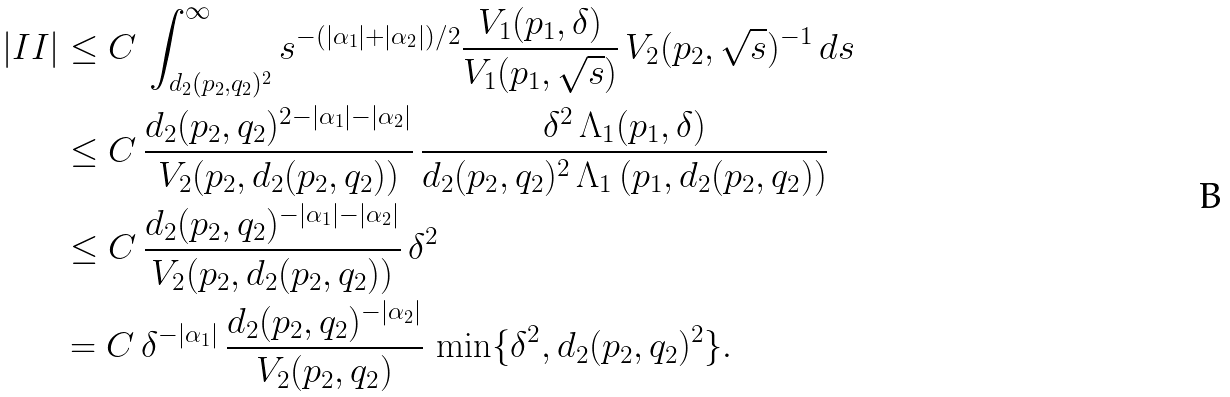<formula> <loc_0><loc_0><loc_500><loc_500>\left | I I \right | & \leq C \, \int _ { d _ { 2 } ( p _ { 2 } , q _ { 2 } ) ^ { 2 } } ^ { \infty } s ^ { - ( | \alpha _ { 1 } | + | \alpha _ { 2 } | ) / 2 } \frac { V _ { 1 } ( p _ { 1 } , \delta ) } { V _ { 1 } ( p _ { 1 } , \sqrt { s } ) } \, V _ { 2 } ( p _ { 2 } , \sqrt { s } ) ^ { - 1 } \, d s \\ & \leq C \, \frac { d _ { 2 } ( p _ { 2 } , q _ { 2 } ) ^ { 2 - | \alpha _ { 1 } | - | \alpha _ { 2 } | } } { V _ { 2 } ( p _ { 2 } , d _ { 2 } ( p _ { 2 } , q _ { 2 } ) ) } \, \frac { \delta ^ { 2 } \, \Lambda _ { 1 } ( p _ { 1 } , \delta ) } { d _ { 2 } ( p _ { 2 } , q _ { 2 } ) ^ { 2 } \, \Lambda _ { 1 } \left ( p _ { 1 } , d _ { 2 } ( p _ { 2 } , q _ { 2 } ) \right ) } \\ & \leq C \, \frac { d _ { 2 } ( p _ { 2 } , q _ { 2 } ) ^ { - | \alpha _ { 1 } | - | \alpha _ { 2 } | } } { V _ { 2 } ( p _ { 2 } , d _ { 2 } ( p _ { 2 } , q _ { 2 } ) ) } \, \delta ^ { 2 } \\ & = C \, \delta ^ { - | \alpha _ { 1 } | } \, \frac { d _ { 2 } ( p _ { 2 } , q _ { 2 } ) ^ { - | \alpha _ { 2 } | } } { V _ { 2 } ( p _ { 2 } , q _ { 2 } ) } \, \min \{ \delta ^ { 2 } , d _ { 2 } ( p _ { 2 } , q _ { 2 } ) ^ { 2 } \} .</formula> 